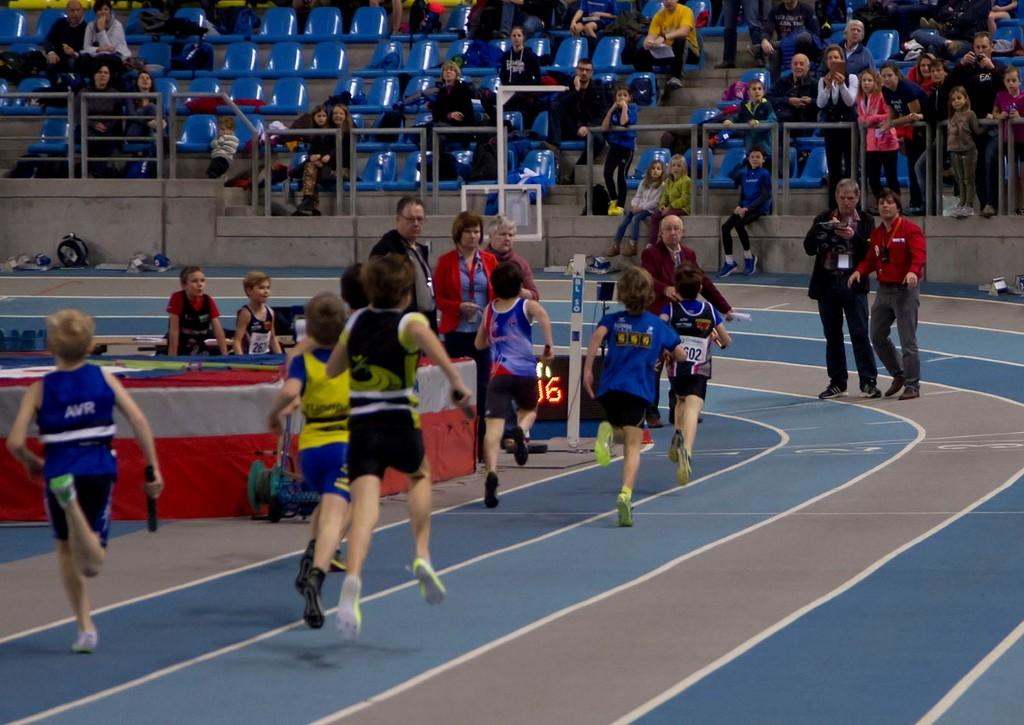What is happening with the group of people in the image? Some people are running on the ground, while others are standing and sitting on chairs. Can you describe the positions of the people in the image? Some people are running, some are standing, and some are sitting on chairs. What else can be seen in the image besides the people? There are objects present in the image. Where is the toothpaste located in the image? There is no toothpaste present in the image. What type of picture is hanging on the wall in the image? There is no picture hanging on the wall in the image. 